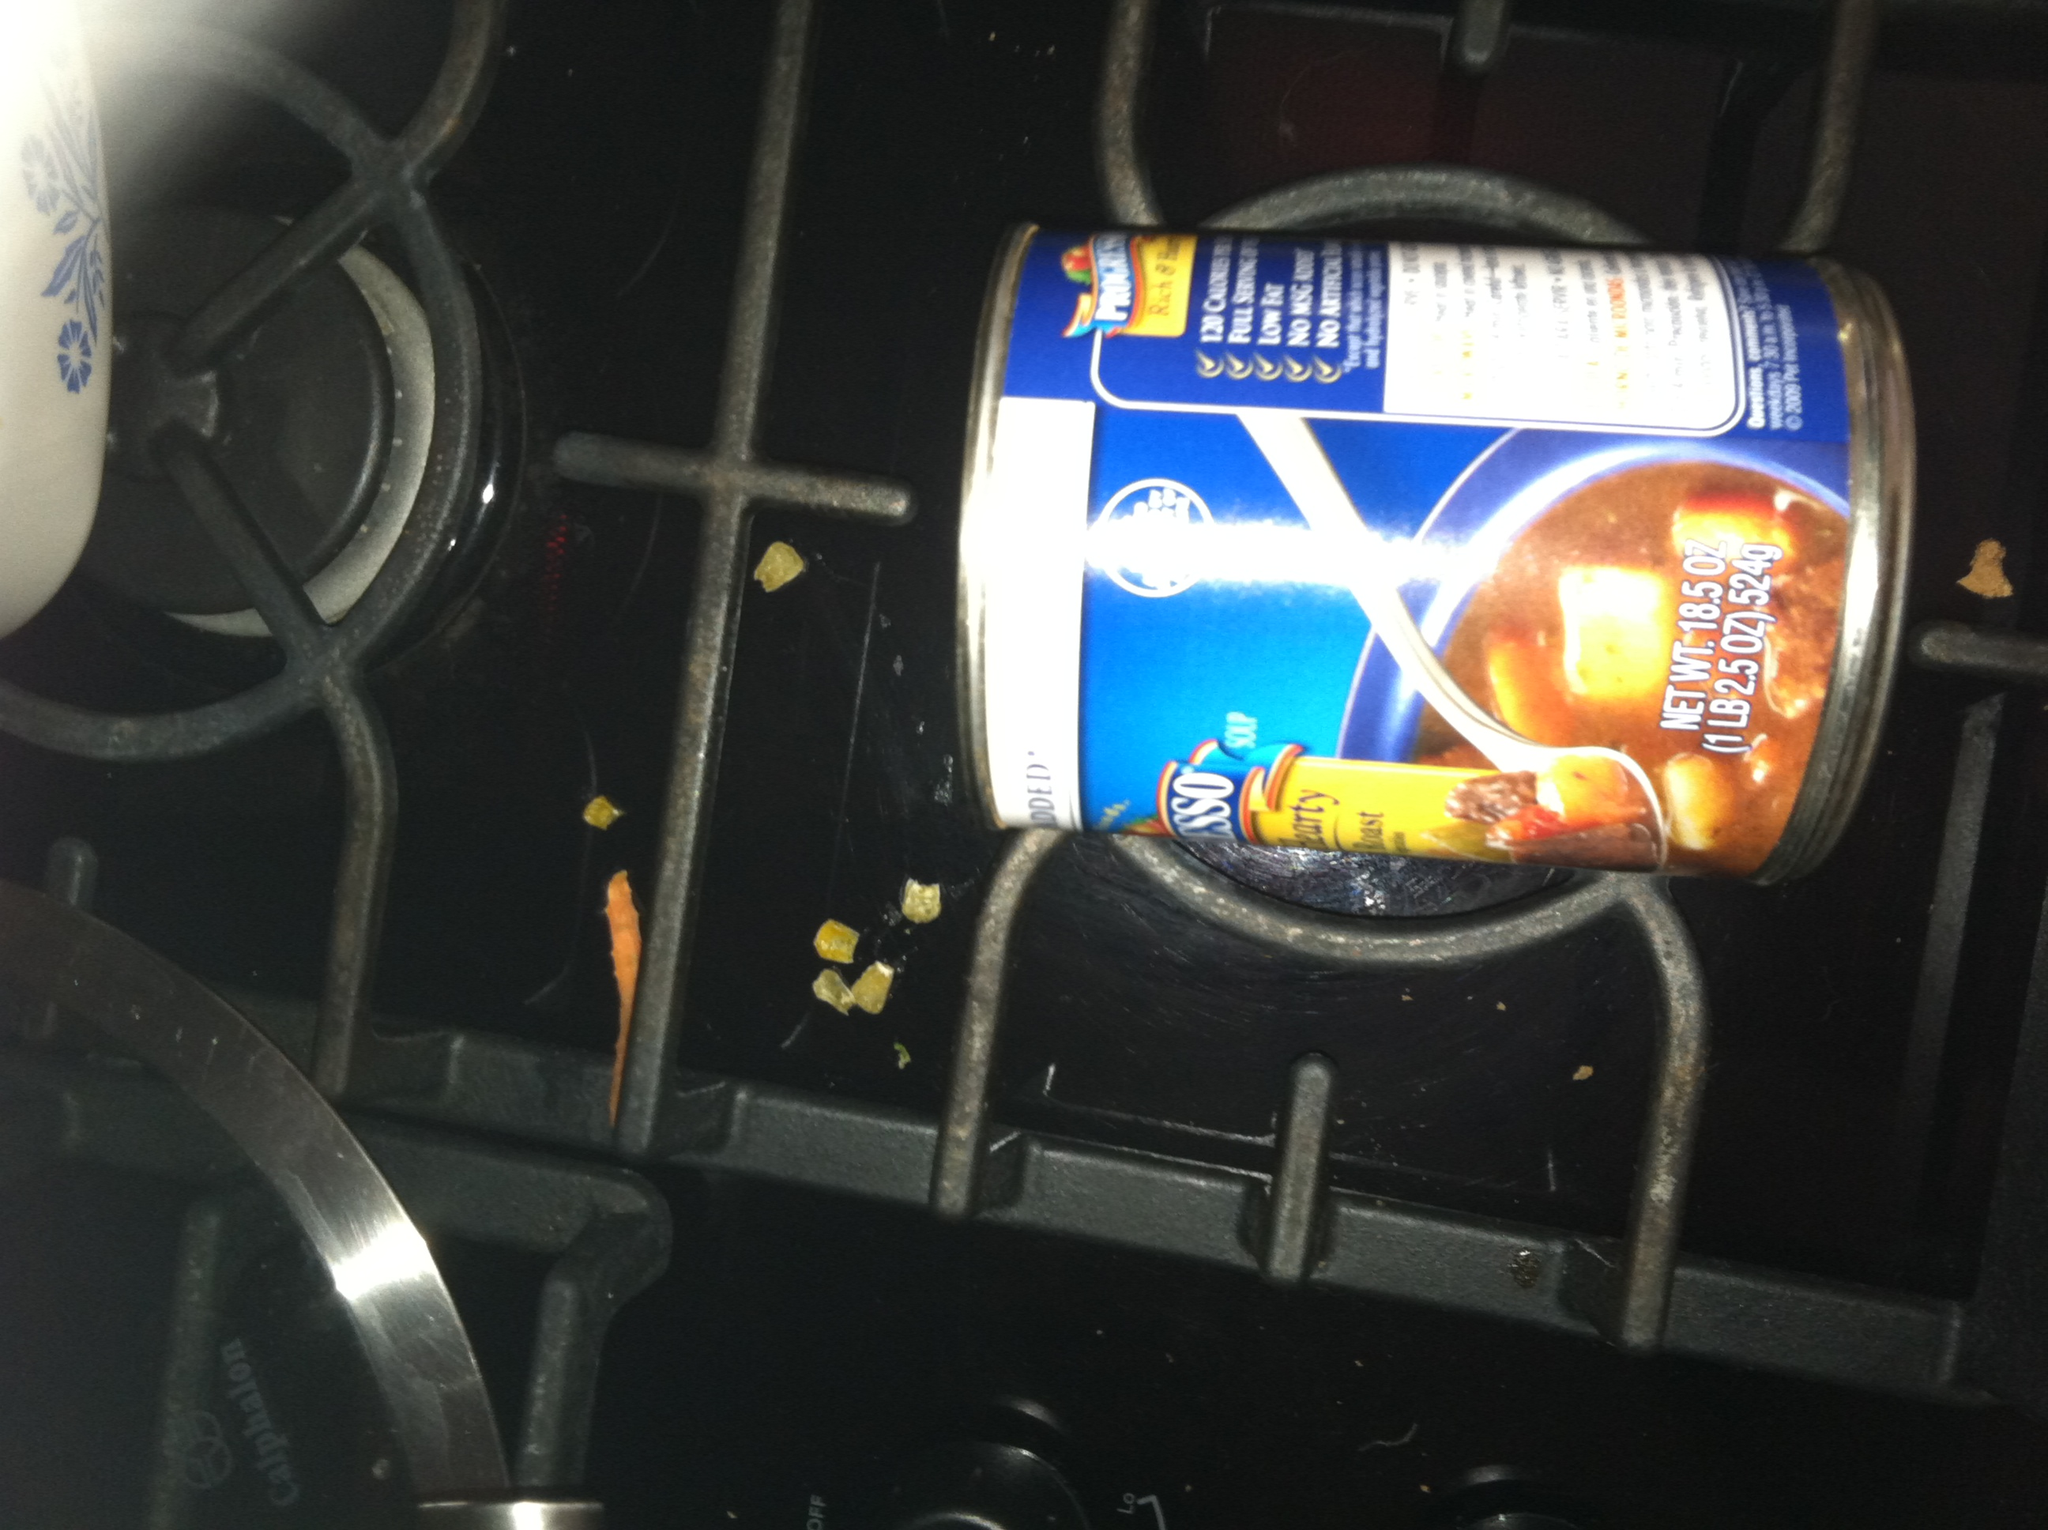This is a test The image shows a stove with a can of soup placed on it, along with some small pieces of food debris scattered around. It seems like a kitchen scene where cooking is about to take place. 